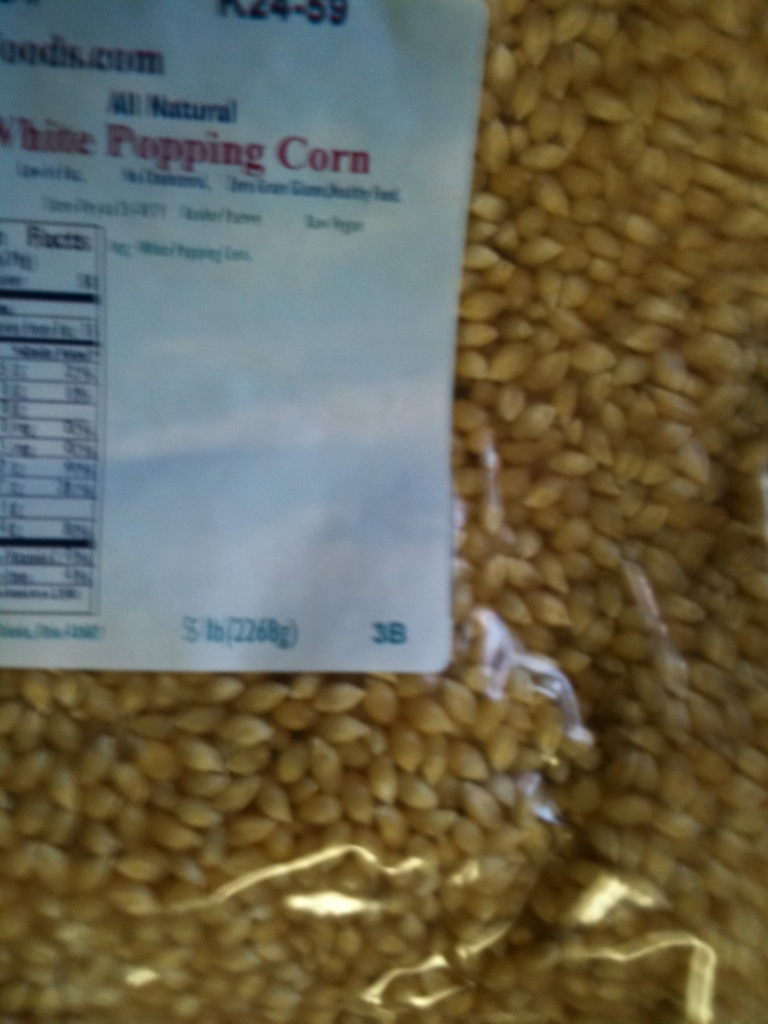How would you use this popping corn to throw a movie night party? For a movie night party, you could use this popping corn to make various flavors of popcorn. Set up a popcorn bar with different seasonings and toppings like melted butter, cheese powder, caramel sauce, chocolate drizzle, and more. Have a selection of classic and current movies, comfy seating, and themed decorations to create a cozy and fun atmosphere. Don't forget to provide drinks and other snacks to complement the popcorn. 